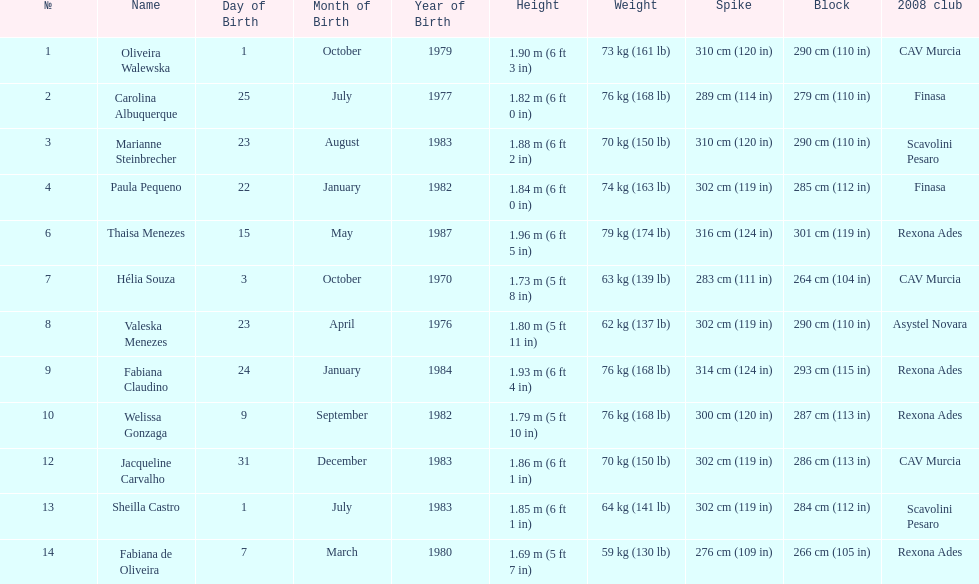Whose weight is the heaviest among the following: fabiana de oliveira, helia souza, or sheilla castro? Sheilla Castro. 